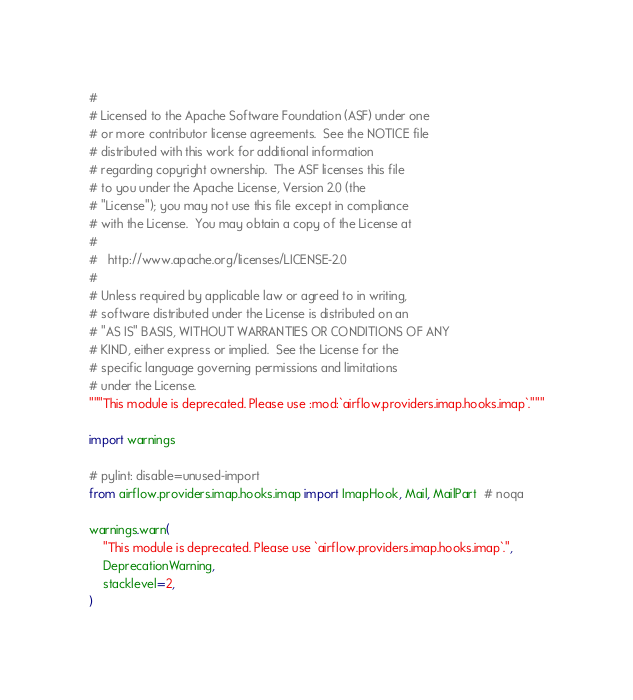Convert code to text. <code><loc_0><loc_0><loc_500><loc_500><_Python_>#
# Licensed to the Apache Software Foundation (ASF) under one
# or more contributor license agreements.  See the NOTICE file
# distributed with this work for additional information
# regarding copyright ownership.  The ASF licenses this file
# to you under the Apache License, Version 2.0 (the
# "License"); you may not use this file except in compliance
# with the License.  You may obtain a copy of the License at
#
#   http://www.apache.org/licenses/LICENSE-2.0
#
# Unless required by applicable law or agreed to in writing,
# software distributed under the License is distributed on an
# "AS IS" BASIS, WITHOUT WARRANTIES OR CONDITIONS OF ANY
# KIND, either express or implied.  See the License for the
# specific language governing permissions and limitations
# under the License.
"""This module is deprecated. Please use :mod:`airflow.providers.imap.hooks.imap`."""

import warnings

# pylint: disable=unused-import
from airflow.providers.imap.hooks.imap import ImapHook, Mail, MailPart  # noqa

warnings.warn(
    "This module is deprecated. Please use `airflow.providers.imap.hooks.imap`.",
    DeprecationWarning,
    stacklevel=2,
)
</code> 